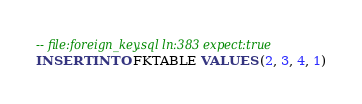Convert code to text. <code><loc_0><loc_0><loc_500><loc_500><_SQL_>-- file:foreign_key.sql ln:383 expect:true
INSERT INTO FKTABLE VALUES (2, 3, 4, 1)
</code> 